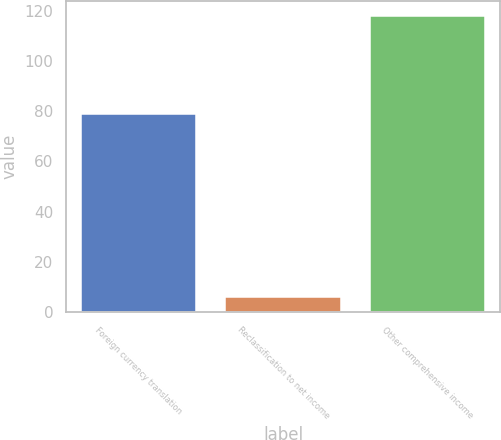Convert chart to OTSL. <chart><loc_0><loc_0><loc_500><loc_500><bar_chart><fcel>Foreign currency translation<fcel>Reclassification to net income<fcel>Other comprehensive income<nl><fcel>79<fcel>6<fcel>118<nl></chart> 